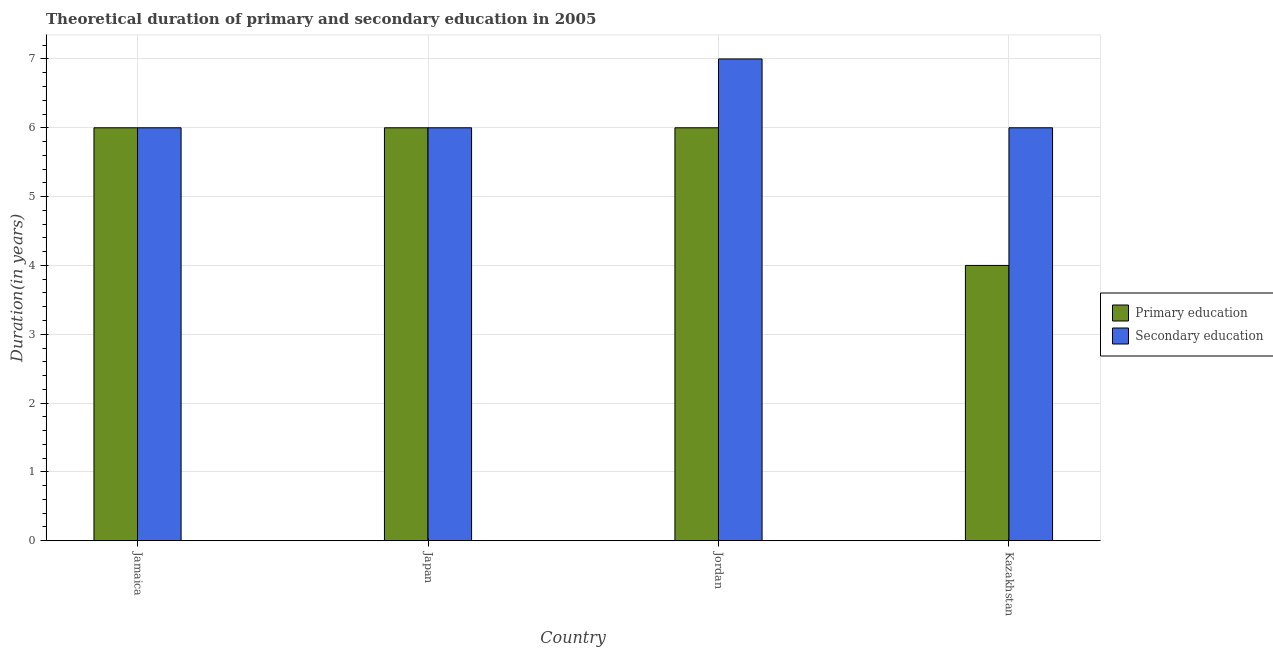Are the number of bars per tick equal to the number of legend labels?
Provide a succinct answer. Yes. How many bars are there on the 4th tick from the left?
Ensure brevity in your answer.  2. What is the label of the 3rd group of bars from the left?
Your answer should be compact. Jordan. What is the duration of secondary education in Japan?
Keep it short and to the point. 6. In which country was the duration of secondary education maximum?
Ensure brevity in your answer.  Jordan. In which country was the duration of primary education minimum?
Offer a very short reply. Kazakhstan. What is the total duration of secondary education in the graph?
Offer a terse response. 25. What is the difference between the duration of secondary education in Japan and the duration of primary education in Kazakhstan?
Provide a succinct answer. 2. What is the average duration of primary education per country?
Provide a short and direct response. 5.5. What is the difference between the duration of secondary education and duration of primary education in Kazakhstan?
Provide a short and direct response. 2. In how many countries, is the duration of primary education greater than 3.6 years?
Your response must be concise. 4. What is the ratio of the duration of secondary education in Jordan to that in Kazakhstan?
Your answer should be compact. 1.17. Is the duration of primary education in Japan less than that in Kazakhstan?
Make the answer very short. No. Is the difference between the duration of secondary education in Japan and Kazakhstan greater than the difference between the duration of primary education in Japan and Kazakhstan?
Your answer should be very brief. No. What is the difference between the highest and the lowest duration of secondary education?
Make the answer very short. 1. What does the 2nd bar from the left in Japan represents?
Ensure brevity in your answer.  Secondary education. How many bars are there?
Provide a short and direct response. 8. Are all the bars in the graph horizontal?
Make the answer very short. No. How many countries are there in the graph?
Offer a terse response. 4. Are the values on the major ticks of Y-axis written in scientific E-notation?
Offer a very short reply. No. Does the graph contain any zero values?
Ensure brevity in your answer.  No. Where does the legend appear in the graph?
Offer a very short reply. Center right. How are the legend labels stacked?
Give a very brief answer. Vertical. What is the title of the graph?
Your answer should be compact. Theoretical duration of primary and secondary education in 2005. What is the label or title of the Y-axis?
Your answer should be very brief. Duration(in years). What is the Duration(in years) of Secondary education in Jamaica?
Your answer should be compact. 6. What is the Duration(in years) of Primary education in Japan?
Provide a short and direct response. 6. What is the Duration(in years) of Secondary education in Japan?
Give a very brief answer. 6. What is the Duration(in years) in Secondary education in Jordan?
Provide a short and direct response. 7. What is the Duration(in years) of Primary education in Kazakhstan?
Provide a succinct answer. 4. What is the Duration(in years) in Secondary education in Kazakhstan?
Offer a terse response. 6. Across all countries, what is the maximum Duration(in years) of Primary education?
Keep it short and to the point. 6. What is the difference between the Duration(in years) in Primary education in Jamaica and that in Japan?
Offer a terse response. 0. What is the difference between the Duration(in years) of Secondary education in Jamaica and that in Kazakhstan?
Offer a very short reply. 0. What is the difference between the Duration(in years) of Primary education in Japan and that in Kazakhstan?
Offer a terse response. 2. What is the difference between the Duration(in years) of Secondary education in Jordan and that in Kazakhstan?
Make the answer very short. 1. What is the difference between the Duration(in years) in Primary education in Jamaica and the Duration(in years) in Secondary education in Kazakhstan?
Keep it short and to the point. 0. What is the difference between the Duration(in years) in Primary education in Japan and the Duration(in years) in Secondary education in Jordan?
Offer a terse response. -1. What is the difference between the Duration(in years) in Primary education in Japan and the Duration(in years) in Secondary education in Kazakhstan?
Offer a terse response. 0. What is the difference between the Duration(in years) of Primary education in Jordan and the Duration(in years) of Secondary education in Kazakhstan?
Your answer should be compact. 0. What is the average Duration(in years) of Primary education per country?
Offer a very short reply. 5.5. What is the average Duration(in years) in Secondary education per country?
Give a very brief answer. 6.25. What is the difference between the Duration(in years) in Primary education and Duration(in years) in Secondary education in Jordan?
Provide a short and direct response. -1. What is the difference between the Duration(in years) of Primary education and Duration(in years) of Secondary education in Kazakhstan?
Offer a very short reply. -2. What is the ratio of the Duration(in years) of Primary education in Jamaica to that in Kazakhstan?
Make the answer very short. 1.5. What is the ratio of the Duration(in years) of Secondary education in Jamaica to that in Kazakhstan?
Give a very brief answer. 1. What is the ratio of the Duration(in years) in Primary education in Japan to that in Kazakhstan?
Offer a very short reply. 1.5. What is the ratio of the Duration(in years) in Secondary education in Japan to that in Kazakhstan?
Make the answer very short. 1. What is the ratio of the Duration(in years) in Secondary education in Jordan to that in Kazakhstan?
Your answer should be compact. 1.17. What is the difference between the highest and the second highest Duration(in years) in Primary education?
Your answer should be very brief. 0. What is the difference between the highest and the second highest Duration(in years) in Secondary education?
Give a very brief answer. 1. 